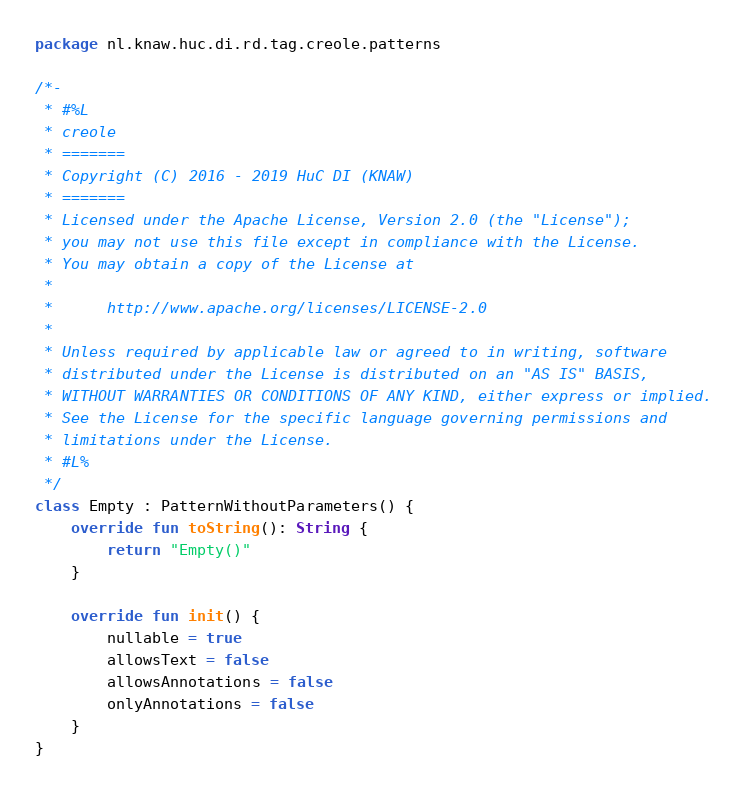Convert code to text. <code><loc_0><loc_0><loc_500><loc_500><_Kotlin_>package nl.knaw.huc.di.rd.tag.creole.patterns

/*-
 * #%L
 * creole
 * =======
 * Copyright (C) 2016 - 2019 HuC DI (KNAW)
 * =======
 * Licensed under the Apache License, Version 2.0 (the "License");
 * you may not use this file except in compliance with the License.
 * You may obtain a copy of the License at
 * 
 *      http://www.apache.org/licenses/LICENSE-2.0
 * 
 * Unless required by applicable law or agreed to in writing, software
 * distributed under the License is distributed on an "AS IS" BASIS,
 * WITHOUT WARRANTIES OR CONDITIONS OF ANY KIND, either express or implied.
 * See the License for the specific language governing permissions and
 * limitations under the License.
 * #L%
 */
class Empty : PatternWithoutParameters() {
    override fun toString(): String {
        return "Empty()"
    }

    override fun init() {
        nullable = true
        allowsText = false
        allowsAnnotations = false
        onlyAnnotations = false
    }
}
</code> 